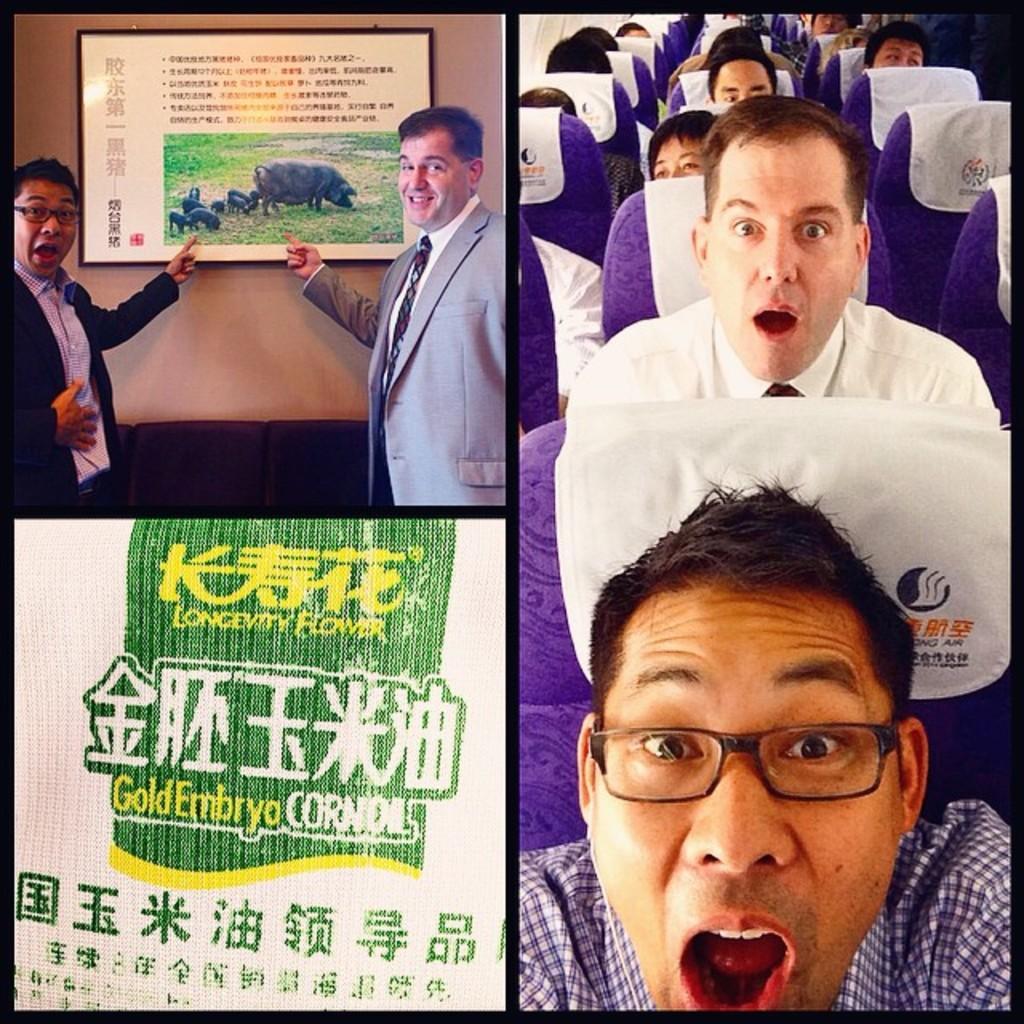How would you summarize this image in a sentence or two? This is a collage edited image. on the left side at the top we can see two men and a board on the wall in the image and at the bottom we can see texts and design are in a cloth and on the right side there are few persons sitting on the seats in a vehicle. 